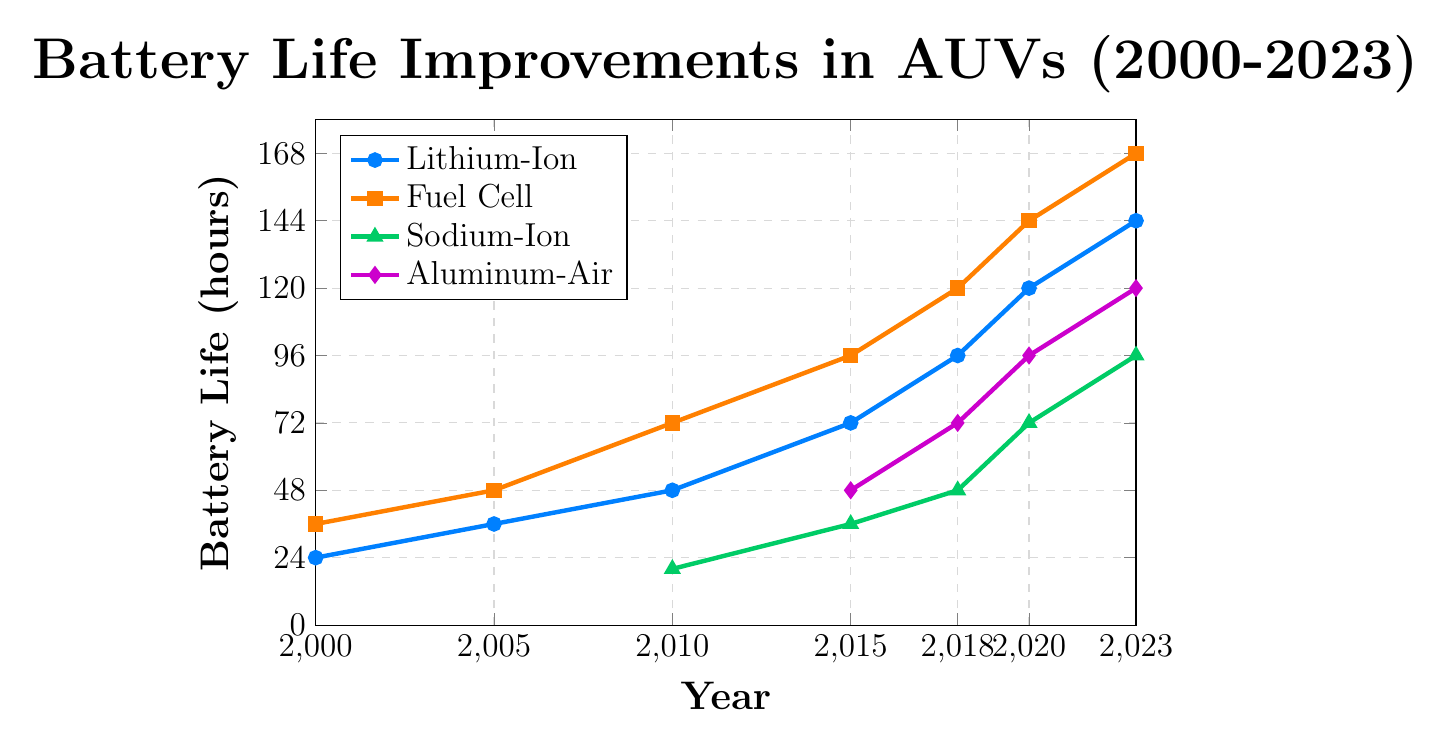What is the overall trend in battery life for Lithium-Ion batteries from 2000 to 2023? The line representing Lithium-Ion battery life shows a consistent increase from 24 hours in 2000 to 144 hours in 2023.
Answer: Increasing Which type of battery had the greatest improvement in battery life from 2010 to 2023? To determine this, we calculate the difference in battery life between 2010 and 2023 for each available battery type. Lithium-Ion: 144 - 48 = 96 hours, Fuel Cell: 168 - 72 = 96 hours, Sodium-Ion: 96 - 20 = 76 hours, Aluminum-Air (not available in 2010). Both Lithium-Ion and Fuel Cell improved by 96 hours.
Answer: Lithium-Ion and Fuel Cell In which year did Sodium-Ion batteries reach 72 hours of battery life? The plot shows Sodium-Ion data points at different years. The Sodium-Ion battery life reached 72 hours in the year 2020.
Answer: 2020 How does the battery life of Fuel Cell batteries in 2023 compare to Aluminum-Air batteries in 2020? From the chart, the Fuel Cell battery life in 2023 is 168 hours, and the Aluminum-Air battery life in 2020 is 96 hours. 168 hours is greater than 96 hours.
Answer: Fuel Cell in 2023 is greater Compare the battery life of Lithium-Ion and Fuel Cell batteries in 2018. From the chart, the Lithium-Ion battery life in 2018 is 96 hours, while the Fuel Cell battery life is 120 hours in the same year.
Answer: Fuel Cell is greater What was the percentage increase in battery life for Lithium-Ion batteries from 2000 to 2023? Calculate the percentage increase using the formula: ((new value - old value) / old value) * 100. For Lithium-Ion batteries: ((144 - 24) / 24) * 100 = 500%.
Answer: 500% Which type of battery reached at least 48 hours of battery life first, and in which year? The first battery to reach 48 hours is identified by examining the plot. The Fuel Cell battery reached 48 hours in 2005.
Answer: Fuel Cell in 2005 What is the minimum battery life for Sodium-Ion batteries in the given data range? Reviewing the plotted data points for Sodium-Ion batteries, the minimum value is 20 hours, which occurred in 2010.
Answer: 20 hours What is the slope of the line for Fuel Cell batteries between 2005 and 2010? The slope can be calculated by taking the difference in battery life divided by the time difference. For Fuel Cell between 2005 and 2010: (72 - 48) / (2010 - 2005) = 24 / 5 = 4.8 hours per year.
Answer: 4.8 hours per year Which battery type has the steepest initial increase in battery life according to the data? Analyze the slope of each battery type from its start to the next available data point (initial segment). The steepest increase is calculated based on the sharp rise. For example, the Aluminum-Air from 2015 to 2018 increases by 24 hours over 3 years, resulting in a rate of 8 hours per year. Reviewing all types, Aluminum-Air has the steepest initial increase.
Answer: Aluminum-Air 